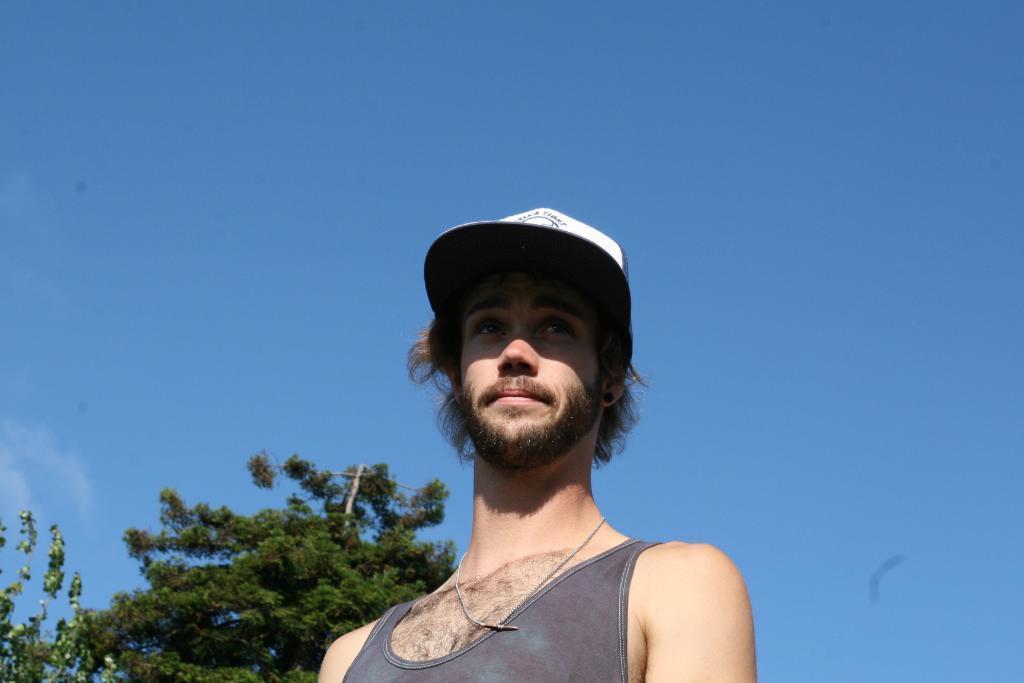Can you describe this image briefly? In the picture I can see a man in the middle of the image. He is wearing a banyan and there is a cap on his head. There are trees on the bottom left side of the picture. There are clouds in the sky. 